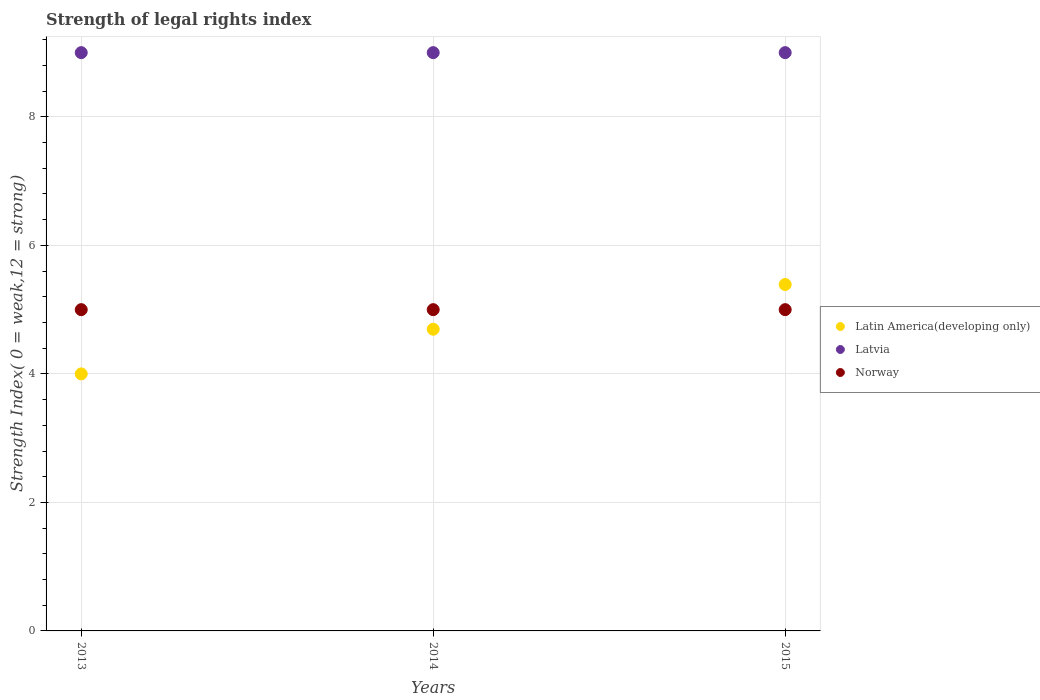How many different coloured dotlines are there?
Make the answer very short. 3. Is the number of dotlines equal to the number of legend labels?
Ensure brevity in your answer.  Yes. What is the strength index in Norway in 2013?
Offer a terse response. 5. Across all years, what is the maximum strength index in Latvia?
Keep it short and to the point. 9. Across all years, what is the minimum strength index in Latin America(developing only)?
Provide a succinct answer. 4. In which year was the strength index in Norway maximum?
Provide a succinct answer. 2013. What is the total strength index in Latin America(developing only) in the graph?
Provide a short and direct response. 14.09. What is the difference between the strength index in Latin America(developing only) in 2013 and that in 2015?
Offer a very short reply. -1.39. What is the difference between the strength index in Norway in 2015 and the strength index in Latvia in 2014?
Provide a succinct answer. -4. In the year 2015, what is the difference between the strength index in Latin America(developing only) and strength index in Norway?
Offer a terse response. 0.39. In how many years, is the strength index in Latin America(developing only) greater than 0.8?
Make the answer very short. 3. What is the ratio of the strength index in Latin America(developing only) in 2014 to that in 2015?
Provide a succinct answer. 0.87. What is the difference between the highest and the second highest strength index in Latvia?
Keep it short and to the point. 0. What is the difference between the highest and the lowest strength index in Latin America(developing only)?
Keep it short and to the point. 1.39. In how many years, is the strength index in Latin America(developing only) greater than the average strength index in Latin America(developing only) taken over all years?
Offer a terse response. 1. Is the strength index in Latvia strictly greater than the strength index in Latin America(developing only) over the years?
Provide a short and direct response. Yes. Is the strength index in Norway strictly less than the strength index in Latvia over the years?
Your response must be concise. Yes. Are the values on the major ticks of Y-axis written in scientific E-notation?
Provide a succinct answer. No. Does the graph contain any zero values?
Ensure brevity in your answer.  No. Does the graph contain grids?
Offer a terse response. Yes. Where does the legend appear in the graph?
Ensure brevity in your answer.  Center right. How are the legend labels stacked?
Provide a short and direct response. Vertical. What is the title of the graph?
Your answer should be very brief. Strength of legal rights index. What is the label or title of the X-axis?
Ensure brevity in your answer.  Years. What is the label or title of the Y-axis?
Ensure brevity in your answer.  Strength Index( 0 = weak,12 = strong). What is the Strength Index( 0 = weak,12 = strong) in Latin America(developing only) in 2013?
Keep it short and to the point. 4. What is the Strength Index( 0 = weak,12 = strong) of Latvia in 2013?
Offer a terse response. 9. What is the Strength Index( 0 = weak,12 = strong) in Norway in 2013?
Offer a terse response. 5. What is the Strength Index( 0 = weak,12 = strong) in Latin America(developing only) in 2014?
Give a very brief answer. 4.7. What is the Strength Index( 0 = weak,12 = strong) in Latin America(developing only) in 2015?
Offer a very short reply. 5.39. Across all years, what is the maximum Strength Index( 0 = weak,12 = strong) of Latin America(developing only)?
Make the answer very short. 5.39. Across all years, what is the maximum Strength Index( 0 = weak,12 = strong) in Norway?
Give a very brief answer. 5. Across all years, what is the minimum Strength Index( 0 = weak,12 = strong) of Latvia?
Offer a terse response. 9. What is the total Strength Index( 0 = weak,12 = strong) of Latin America(developing only) in the graph?
Your answer should be very brief. 14.09. What is the total Strength Index( 0 = weak,12 = strong) in Norway in the graph?
Provide a short and direct response. 15. What is the difference between the Strength Index( 0 = weak,12 = strong) of Latin America(developing only) in 2013 and that in 2014?
Give a very brief answer. -0.7. What is the difference between the Strength Index( 0 = weak,12 = strong) of Latvia in 2013 and that in 2014?
Offer a very short reply. 0. What is the difference between the Strength Index( 0 = weak,12 = strong) in Latin America(developing only) in 2013 and that in 2015?
Offer a terse response. -1.39. What is the difference between the Strength Index( 0 = weak,12 = strong) in Latvia in 2013 and that in 2015?
Provide a short and direct response. 0. What is the difference between the Strength Index( 0 = weak,12 = strong) in Norway in 2013 and that in 2015?
Keep it short and to the point. 0. What is the difference between the Strength Index( 0 = weak,12 = strong) in Latin America(developing only) in 2014 and that in 2015?
Ensure brevity in your answer.  -0.7. What is the difference between the Strength Index( 0 = weak,12 = strong) in Latin America(developing only) in 2013 and the Strength Index( 0 = weak,12 = strong) in Norway in 2014?
Give a very brief answer. -1. What is the difference between the Strength Index( 0 = weak,12 = strong) in Latin America(developing only) in 2013 and the Strength Index( 0 = weak,12 = strong) in Latvia in 2015?
Ensure brevity in your answer.  -5. What is the difference between the Strength Index( 0 = weak,12 = strong) of Latin America(developing only) in 2014 and the Strength Index( 0 = weak,12 = strong) of Latvia in 2015?
Offer a terse response. -4.3. What is the difference between the Strength Index( 0 = weak,12 = strong) in Latin America(developing only) in 2014 and the Strength Index( 0 = weak,12 = strong) in Norway in 2015?
Provide a succinct answer. -0.3. What is the average Strength Index( 0 = weak,12 = strong) in Latin America(developing only) per year?
Keep it short and to the point. 4.7. In the year 2013, what is the difference between the Strength Index( 0 = weak,12 = strong) of Latin America(developing only) and Strength Index( 0 = weak,12 = strong) of Latvia?
Your answer should be compact. -5. In the year 2013, what is the difference between the Strength Index( 0 = weak,12 = strong) in Latvia and Strength Index( 0 = weak,12 = strong) in Norway?
Ensure brevity in your answer.  4. In the year 2014, what is the difference between the Strength Index( 0 = weak,12 = strong) of Latin America(developing only) and Strength Index( 0 = weak,12 = strong) of Latvia?
Make the answer very short. -4.3. In the year 2014, what is the difference between the Strength Index( 0 = weak,12 = strong) in Latin America(developing only) and Strength Index( 0 = weak,12 = strong) in Norway?
Offer a terse response. -0.3. In the year 2015, what is the difference between the Strength Index( 0 = weak,12 = strong) in Latin America(developing only) and Strength Index( 0 = weak,12 = strong) in Latvia?
Give a very brief answer. -3.61. In the year 2015, what is the difference between the Strength Index( 0 = weak,12 = strong) of Latin America(developing only) and Strength Index( 0 = weak,12 = strong) of Norway?
Keep it short and to the point. 0.39. In the year 2015, what is the difference between the Strength Index( 0 = weak,12 = strong) of Latvia and Strength Index( 0 = weak,12 = strong) of Norway?
Keep it short and to the point. 4. What is the ratio of the Strength Index( 0 = weak,12 = strong) of Latin America(developing only) in 2013 to that in 2014?
Provide a succinct answer. 0.85. What is the ratio of the Strength Index( 0 = weak,12 = strong) of Latvia in 2013 to that in 2014?
Your answer should be compact. 1. What is the ratio of the Strength Index( 0 = weak,12 = strong) in Norway in 2013 to that in 2014?
Your answer should be compact. 1. What is the ratio of the Strength Index( 0 = weak,12 = strong) in Latin America(developing only) in 2013 to that in 2015?
Your response must be concise. 0.74. What is the ratio of the Strength Index( 0 = weak,12 = strong) of Latin America(developing only) in 2014 to that in 2015?
Give a very brief answer. 0.87. What is the difference between the highest and the second highest Strength Index( 0 = weak,12 = strong) in Latin America(developing only)?
Your answer should be compact. 0.7. What is the difference between the highest and the second highest Strength Index( 0 = weak,12 = strong) of Norway?
Ensure brevity in your answer.  0. What is the difference between the highest and the lowest Strength Index( 0 = weak,12 = strong) in Latin America(developing only)?
Offer a terse response. 1.39. What is the difference between the highest and the lowest Strength Index( 0 = weak,12 = strong) of Latvia?
Offer a terse response. 0. What is the difference between the highest and the lowest Strength Index( 0 = weak,12 = strong) in Norway?
Ensure brevity in your answer.  0. 